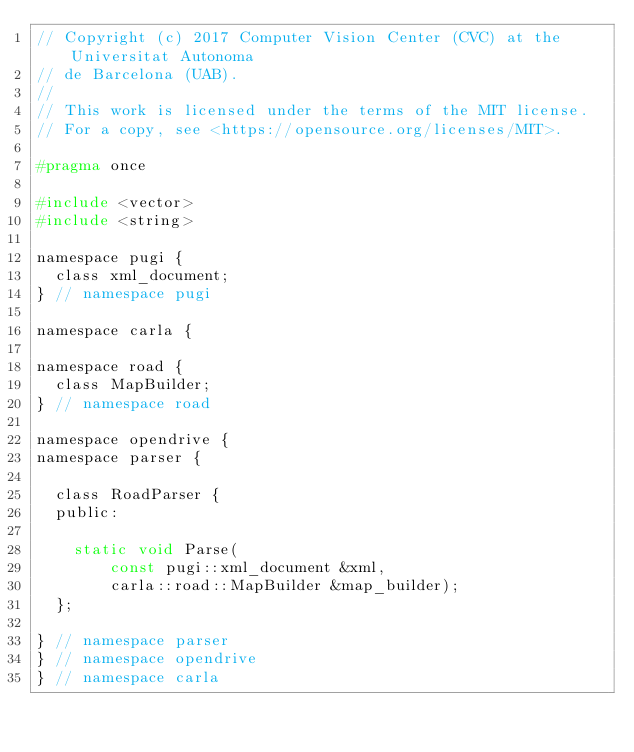<code> <loc_0><loc_0><loc_500><loc_500><_C_>// Copyright (c) 2017 Computer Vision Center (CVC) at the Universitat Autonoma
// de Barcelona (UAB).
//
// This work is licensed under the terms of the MIT license.
// For a copy, see <https://opensource.org/licenses/MIT>.

#pragma once

#include <vector>
#include <string>

namespace pugi {
  class xml_document;
} // namespace pugi

namespace carla {

namespace road {
  class MapBuilder;
} // namespace road

namespace opendrive {
namespace parser {

  class RoadParser {
  public:

    static void Parse(
        const pugi::xml_document &xml,
        carla::road::MapBuilder &map_builder);
  };

} // namespace parser
} // namespace opendrive
} // namespace carla
</code> 